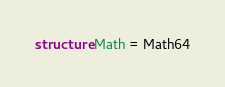Convert code to text. <code><loc_0><loc_0><loc_500><loc_500><_SML_>structure Math = Math64
</code> 